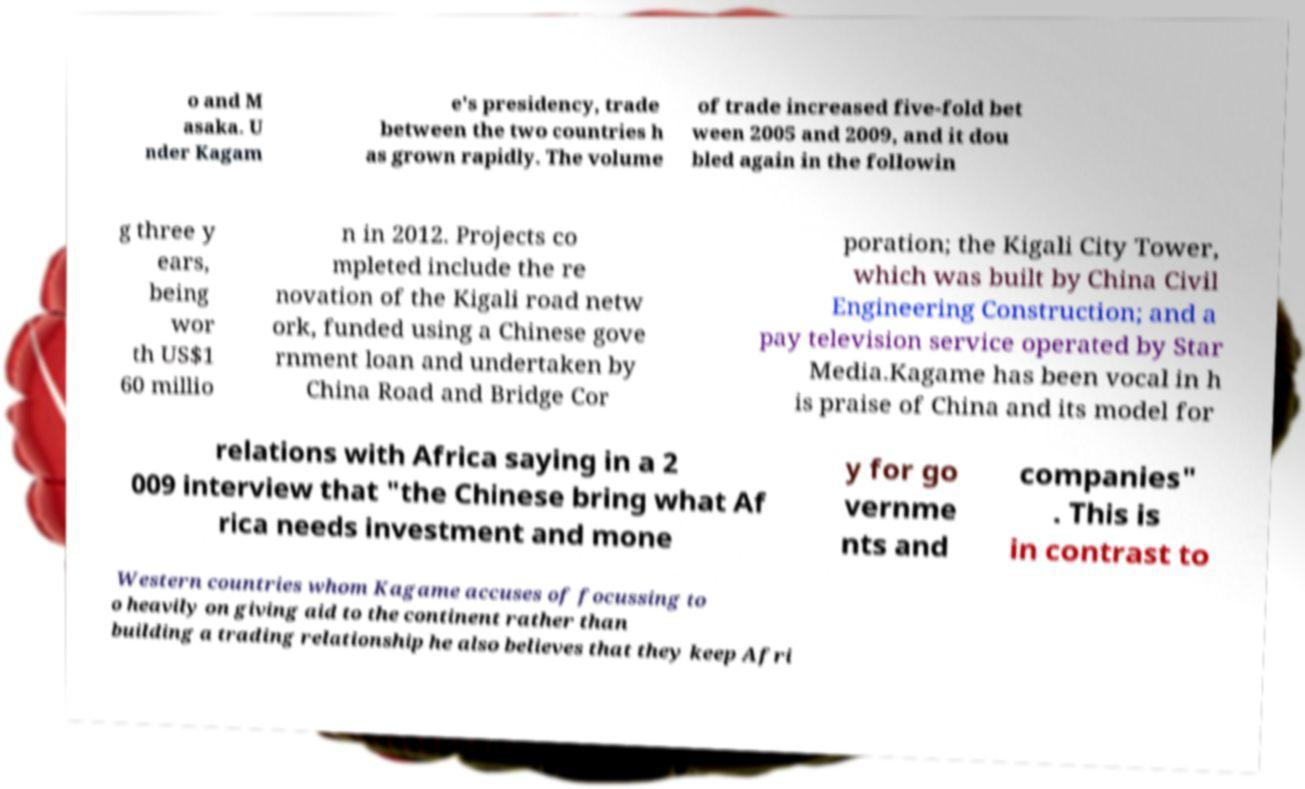Can you accurately transcribe the text from the provided image for me? o and M asaka. U nder Kagam e's presidency, trade between the two countries h as grown rapidly. The volume of trade increased five-fold bet ween 2005 and 2009, and it dou bled again in the followin g three y ears, being wor th US$1 60 millio n in 2012. Projects co mpleted include the re novation of the Kigali road netw ork, funded using a Chinese gove rnment loan and undertaken by China Road and Bridge Cor poration; the Kigali City Tower, which was built by China Civil Engineering Construction; and a pay television service operated by Star Media.Kagame has been vocal in h is praise of China and its model for relations with Africa saying in a 2 009 interview that "the Chinese bring what Af rica needs investment and mone y for go vernme nts and companies" . This is in contrast to Western countries whom Kagame accuses of focussing to o heavily on giving aid to the continent rather than building a trading relationship he also believes that they keep Afri 